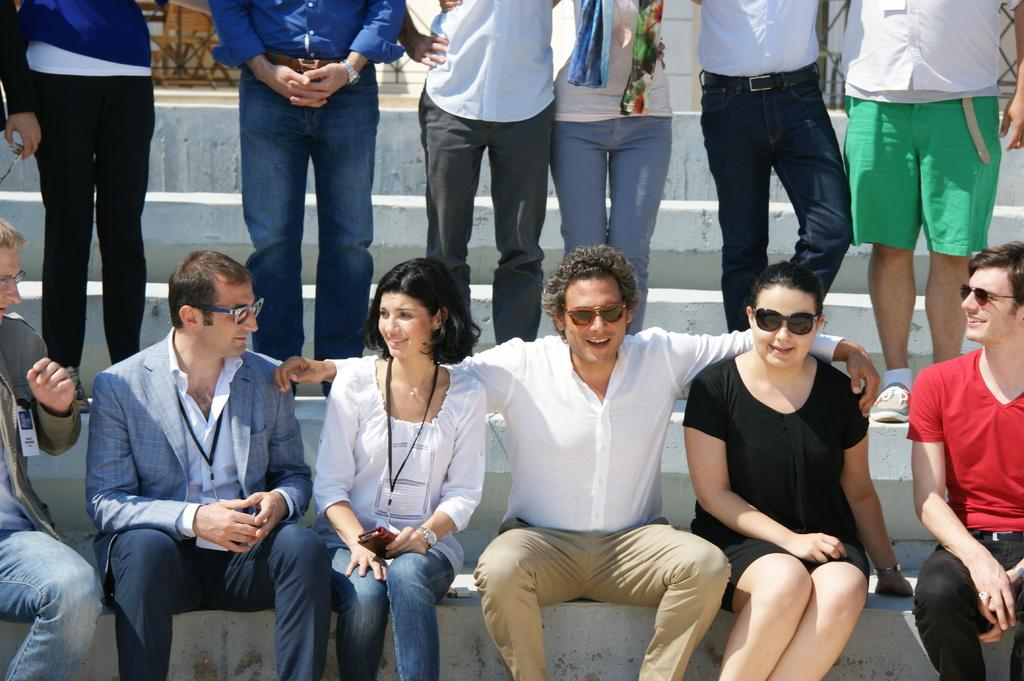What are the people in the image doing? The people in the image are sitting on the stairs. Can you describe what one of the people is holding? A woman is holding a mobile phone in her hand. Are there any other people visible in the image? Yes, there are other people standing on the stairs in the background. What type of street is visible in the image? There is no street visible in the image; it features people sitting on stairs. Can you see any stars in the image? There are no stars visible in the image. 